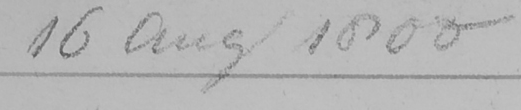Can you tell me what this handwritten text says? 16 Aug 1800 